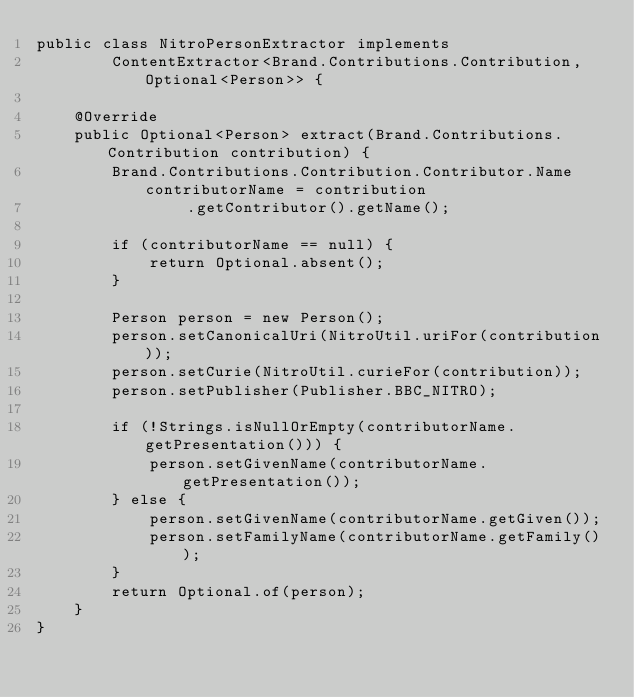Convert code to text. <code><loc_0><loc_0><loc_500><loc_500><_Java_>public class NitroPersonExtractor implements
        ContentExtractor<Brand.Contributions.Contribution, Optional<Person>> {

    @Override
    public Optional<Person> extract(Brand.Contributions.Contribution contribution) {
        Brand.Contributions.Contribution.Contributor.Name contributorName = contribution
                .getContributor().getName();

        if (contributorName == null) {
            return Optional.absent();
        }

        Person person = new Person();
        person.setCanonicalUri(NitroUtil.uriFor(contribution));
        person.setCurie(NitroUtil.curieFor(contribution));
        person.setPublisher(Publisher.BBC_NITRO);

        if (!Strings.isNullOrEmpty(contributorName.getPresentation())) {
            person.setGivenName(contributorName.getPresentation());
        } else {
            person.setGivenName(contributorName.getGiven());
            person.setFamilyName(contributorName.getFamily());
        }
        return Optional.of(person);
    }
}
</code> 